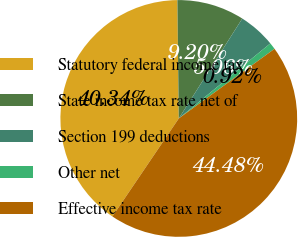Convert chart to OTSL. <chart><loc_0><loc_0><loc_500><loc_500><pie_chart><fcel>Statutory federal income tax<fcel>State income tax rate net of<fcel>Section 199 deductions<fcel>Other net<fcel>Effective income tax rate<nl><fcel>40.34%<fcel>9.2%<fcel>5.06%<fcel>0.92%<fcel>44.48%<nl></chart> 